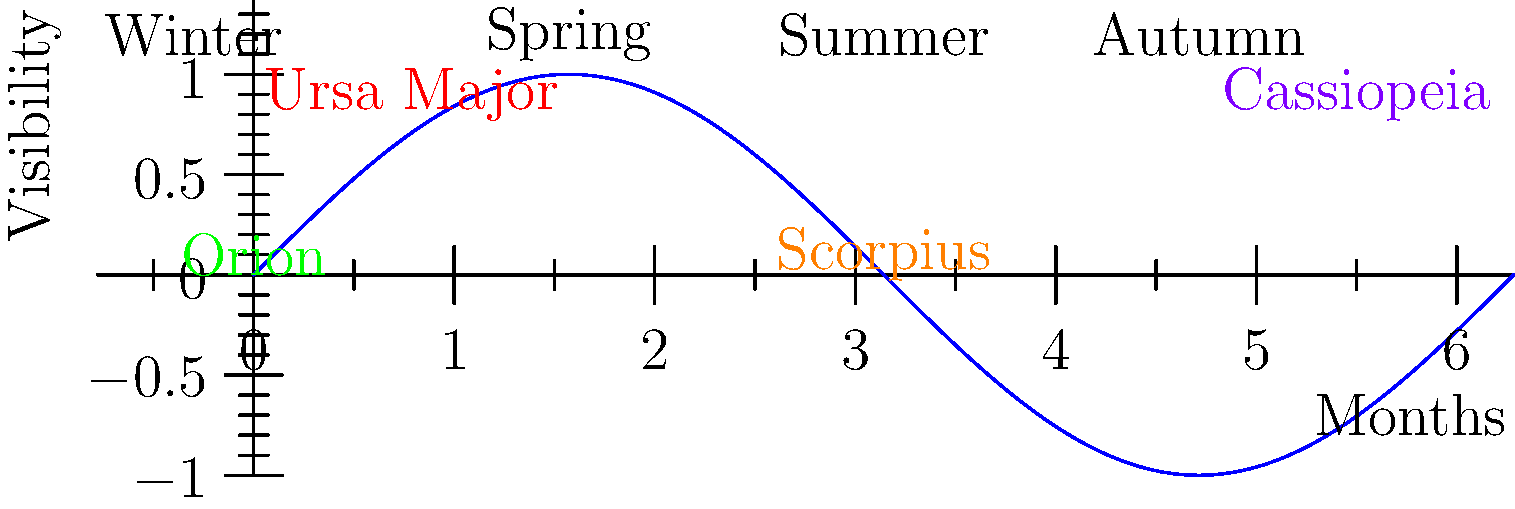Based on the graph showing the visibility of constellations throughout the year in Turkey, which constellation is most prominent during the winter months and could potentially be used as a celestial reference point for nighttime navigation by displaced people? To answer this question, let's analyze the graph step-by-step:

1. The x-axis represents the months of the year, starting from winter on the left and progressing through spring, summer, and autumn.

2. The y-axis represents the visibility of constellations, with higher points indicating better visibility.

3. Four constellations are labeled on the graph: Ursa Major, Orion, Scorpius, and Cassiopeia.

4. Looking at the winter months (far left of the graph), we can see that Orion is at its highest point of visibility during this time.

5. Orion is represented by the green label near the bottom left of the graph, showing high visibility in winter and low visibility in summer.

6. Orion is known for its distinctive pattern, including the "Belt of Orion," which makes it easily recognizable in the night sky.

7. Given its high visibility during winter and its easily identifiable features, Orion would be an excellent celestial reference point for nighttime navigation.

8. Other constellations like Ursa Major and Cassiopeia are also visible in winter, but Orion's prominence during this season makes it particularly useful.
Answer: Orion 